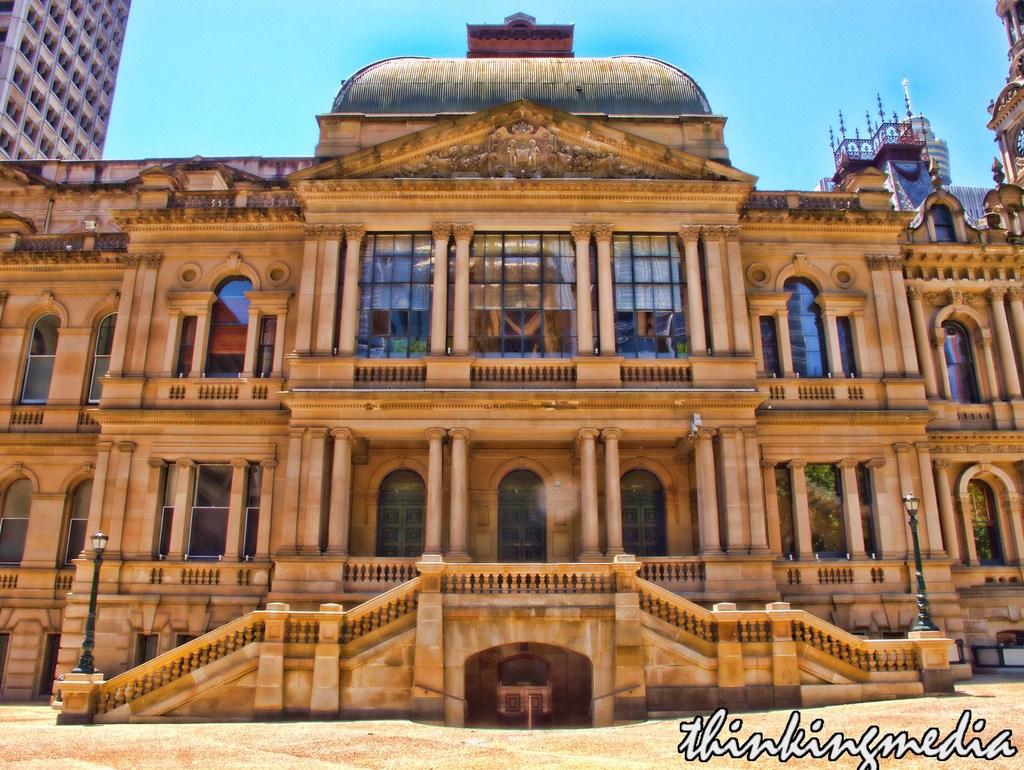What is the name of the album?
Ensure brevity in your answer.  Thinkingmedia. 